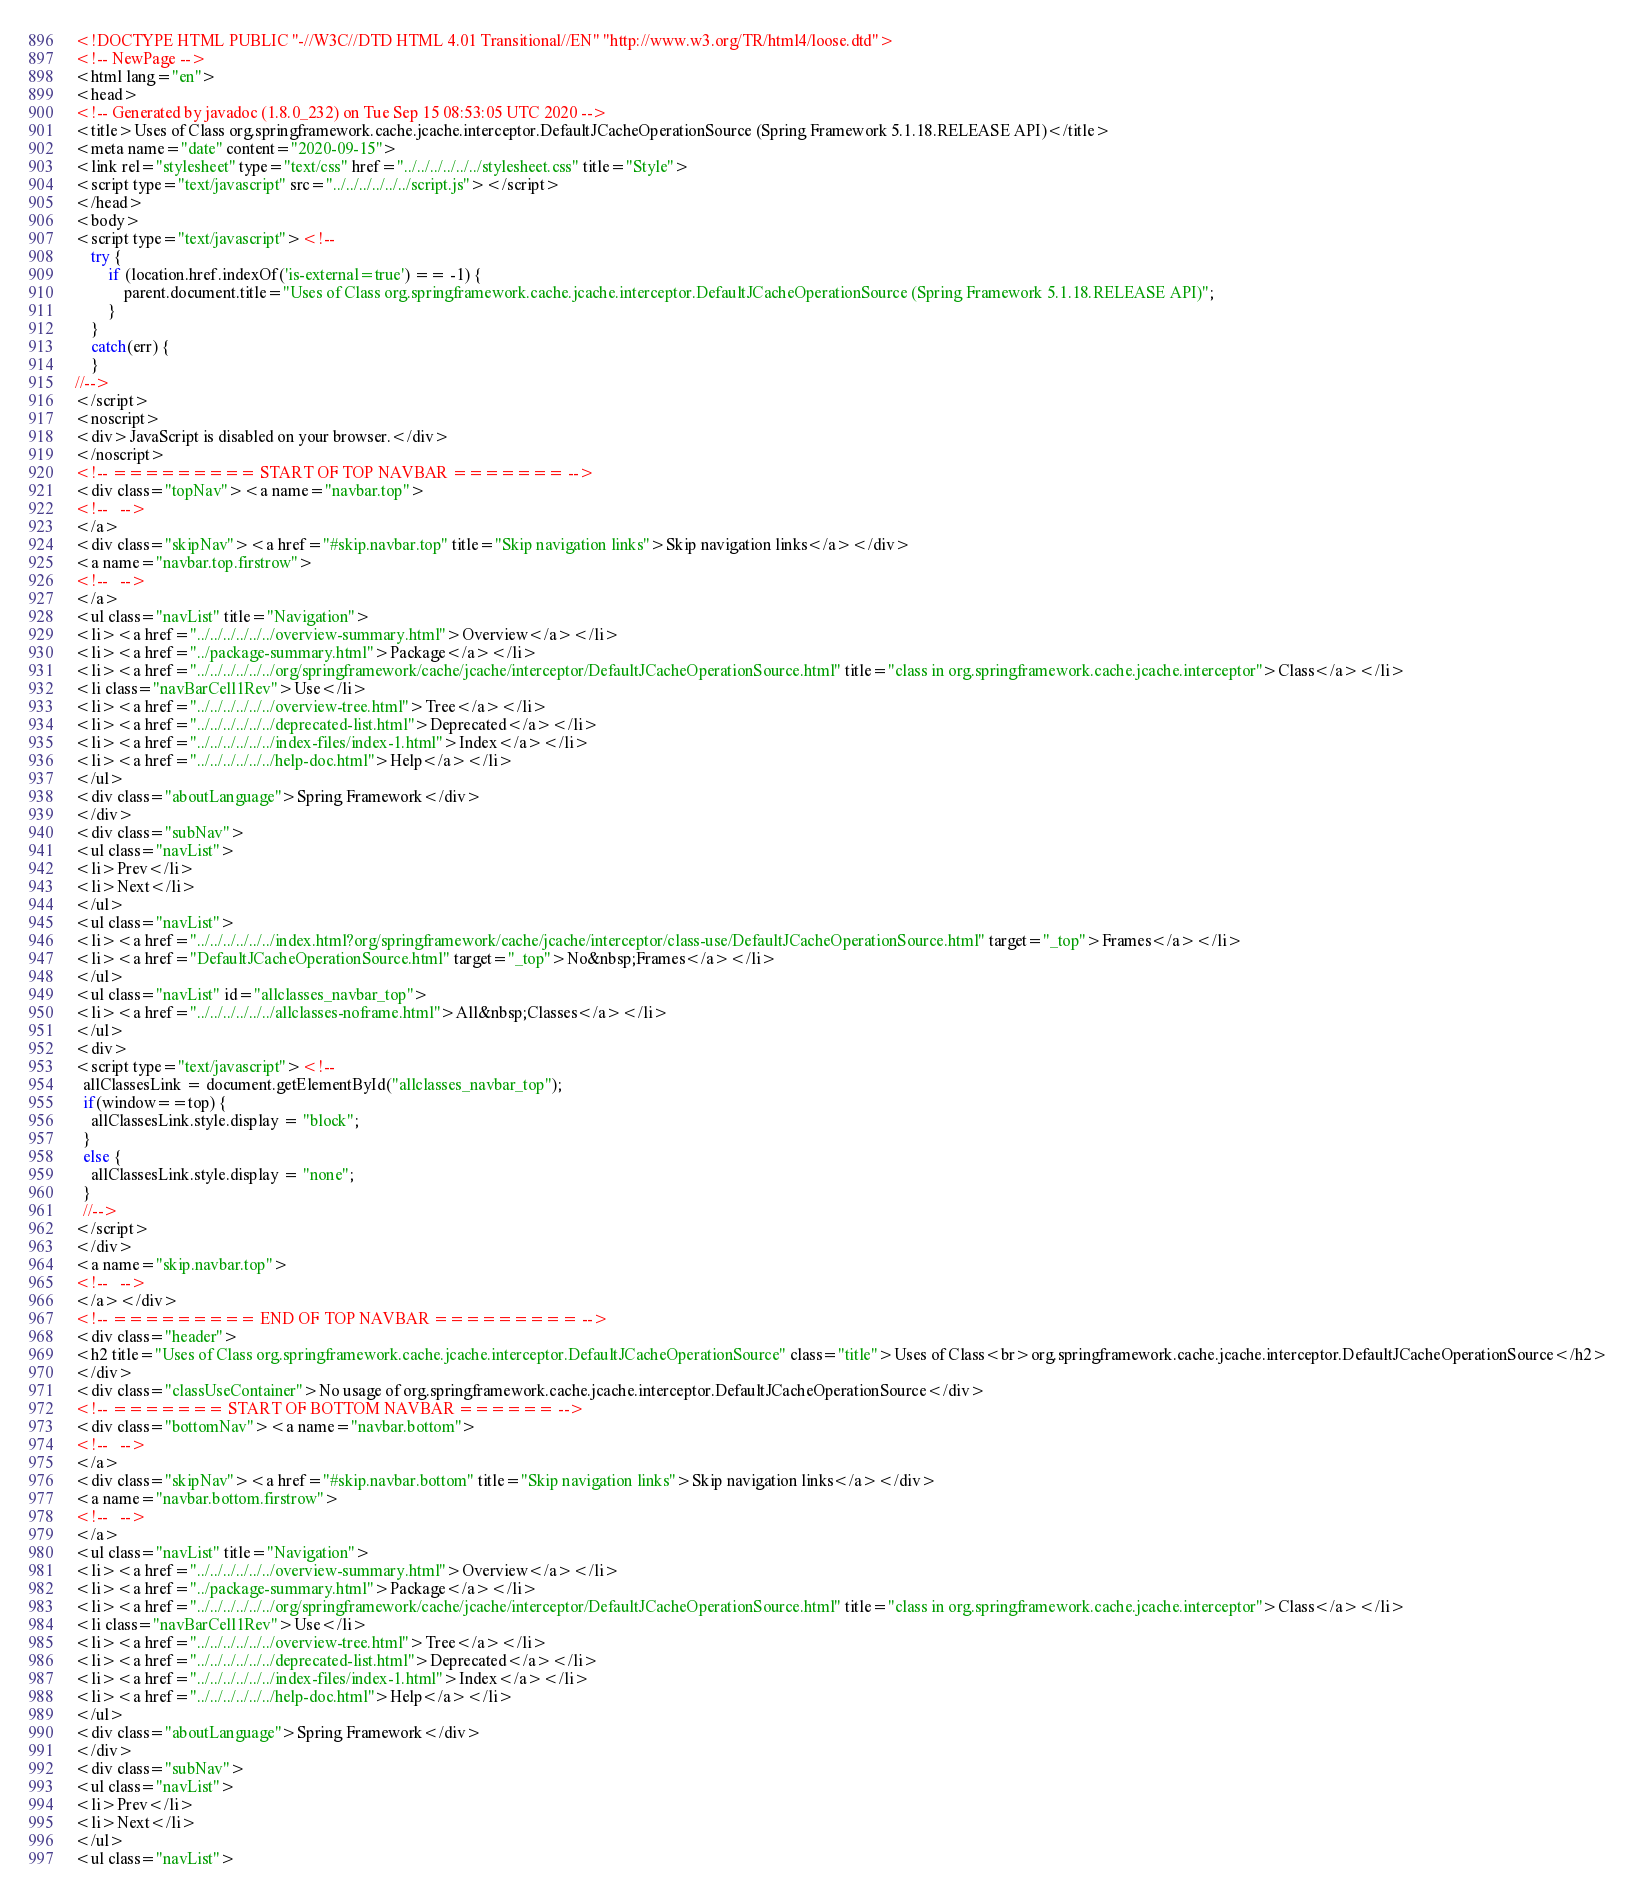Convert code to text. <code><loc_0><loc_0><loc_500><loc_500><_HTML_><!DOCTYPE HTML PUBLIC "-//W3C//DTD HTML 4.01 Transitional//EN" "http://www.w3.org/TR/html4/loose.dtd">
<!-- NewPage -->
<html lang="en">
<head>
<!-- Generated by javadoc (1.8.0_232) on Tue Sep 15 08:53:05 UTC 2020 -->
<title>Uses of Class org.springframework.cache.jcache.interceptor.DefaultJCacheOperationSource (Spring Framework 5.1.18.RELEASE API)</title>
<meta name="date" content="2020-09-15">
<link rel="stylesheet" type="text/css" href="../../../../../../stylesheet.css" title="Style">
<script type="text/javascript" src="../../../../../../script.js"></script>
</head>
<body>
<script type="text/javascript"><!--
    try {
        if (location.href.indexOf('is-external=true') == -1) {
            parent.document.title="Uses of Class org.springframework.cache.jcache.interceptor.DefaultJCacheOperationSource (Spring Framework 5.1.18.RELEASE API)";
        }
    }
    catch(err) {
    }
//-->
</script>
<noscript>
<div>JavaScript is disabled on your browser.</div>
</noscript>
<!-- ========= START OF TOP NAVBAR ======= -->
<div class="topNav"><a name="navbar.top">
<!--   -->
</a>
<div class="skipNav"><a href="#skip.navbar.top" title="Skip navigation links">Skip navigation links</a></div>
<a name="navbar.top.firstrow">
<!--   -->
</a>
<ul class="navList" title="Navigation">
<li><a href="../../../../../../overview-summary.html">Overview</a></li>
<li><a href="../package-summary.html">Package</a></li>
<li><a href="../../../../../../org/springframework/cache/jcache/interceptor/DefaultJCacheOperationSource.html" title="class in org.springframework.cache.jcache.interceptor">Class</a></li>
<li class="navBarCell1Rev">Use</li>
<li><a href="../../../../../../overview-tree.html">Tree</a></li>
<li><a href="../../../../../../deprecated-list.html">Deprecated</a></li>
<li><a href="../../../../../../index-files/index-1.html">Index</a></li>
<li><a href="../../../../../../help-doc.html">Help</a></li>
</ul>
<div class="aboutLanguage">Spring Framework</div>
</div>
<div class="subNav">
<ul class="navList">
<li>Prev</li>
<li>Next</li>
</ul>
<ul class="navList">
<li><a href="../../../../../../index.html?org/springframework/cache/jcache/interceptor/class-use/DefaultJCacheOperationSource.html" target="_top">Frames</a></li>
<li><a href="DefaultJCacheOperationSource.html" target="_top">No&nbsp;Frames</a></li>
</ul>
<ul class="navList" id="allclasses_navbar_top">
<li><a href="../../../../../../allclasses-noframe.html">All&nbsp;Classes</a></li>
</ul>
<div>
<script type="text/javascript"><!--
  allClassesLink = document.getElementById("allclasses_navbar_top");
  if(window==top) {
    allClassesLink.style.display = "block";
  }
  else {
    allClassesLink.style.display = "none";
  }
  //-->
</script>
</div>
<a name="skip.navbar.top">
<!--   -->
</a></div>
<!-- ========= END OF TOP NAVBAR ========= -->
<div class="header">
<h2 title="Uses of Class org.springframework.cache.jcache.interceptor.DefaultJCacheOperationSource" class="title">Uses of Class<br>org.springframework.cache.jcache.interceptor.DefaultJCacheOperationSource</h2>
</div>
<div class="classUseContainer">No usage of org.springframework.cache.jcache.interceptor.DefaultJCacheOperationSource</div>
<!-- ======= START OF BOTTOM NAVBAR ====== -->
<div class="bottomNav"><a name="navbar.bottom">
<!--   -->
</a>
<div class="skipNav"><a href="#skip.navbar.bottom" title="Skip navigation links">Skip navigation links</a></div>
<a name="navbar.bottom.firstrow">
<!--   -->
</a>
<ul class="navList" title="Navigation">
<li><a href="../../../../../../overview-summary.html">Overview</a></li>
<li><a href="../package-summary.html">Package</a></li>
<li><a href="../../../../../../org/springframework/cache/jcache/interceptor/DefaultJCacheOperationSource.html" title="class in org.springframework.cache.jcache.interceptor">Class</a></li>
<li class="navBarCell1Rev">Use</li>
<li><a href="../../../../../../overview-tree.html">Tree</a></li>
<li><a href="../../../../../../deprecated-list.html">Deprecated</a></li>
<li><a href="../../../../../../index-files/index-1.html">Index</a></li>
<li><a href="../../../../../../help-doc.html">Help</a></li>
</ul>
<div class="aboutLanguage">Spring Framework</div>
</div>
<div class="subNav">
<ul class="navList">
<li>Prev</li>
<li>Next</li>
</ul>
<ul class="navList"></code> 